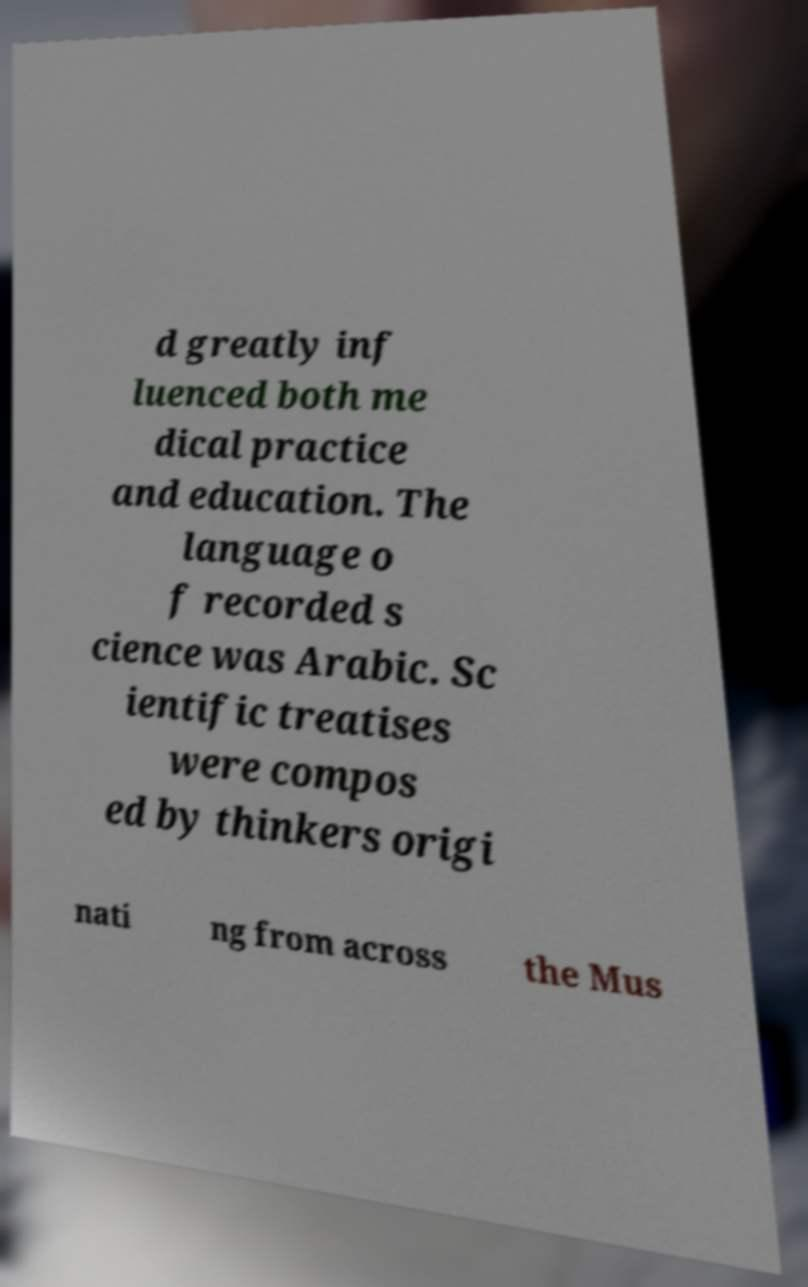There's text embedded in this image that I need extracted. Can you transcribe it verbatim? d greatly inf luenced both me dical practice and education. The language o f recorded s cience was Arabic. Sc ientific treatises were compos ed by thinkers origi nati ng from across the Mus 